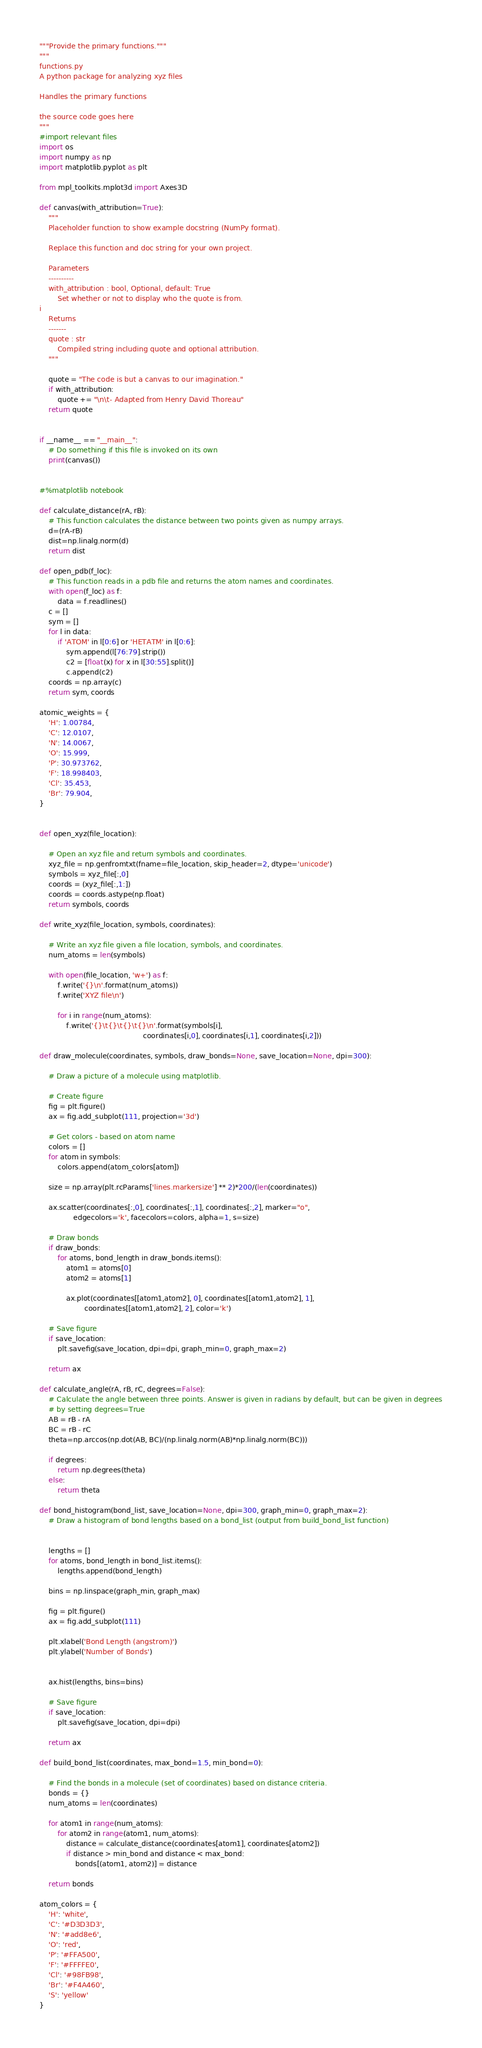Convert code to text. <code><loc_0><loc_0><loc_500><loc_500><_Python_>"""Provide the primary functions."""
"""
functions.py
A python package for analyzing xyz files

Handles the primary functions

the source code goes here
"""
#import relevant files
import os
import numpy as np
import matplotlib.pyplot as plt

from mpl_toolkits.mplot3d import Axes3D

def canvas(with_attribution=True):
    """
    Placeholder function to show example docstring (NumPy format).

    Replace this function and doc string for your own project.

    Parameters
    ----------
    with_attribution : bool, Optional, default: True
        Set whether or not to display who the quote is from.
i
    Returns
    -------
    quote : str
        Compiled string including quote and optional attribution.
    """

    quote = "The code is but a canvas to our imagination."
    if with_attribution:
        quote += "\n\t- Adapted from Henry David Thoreau"
    return quote


if __name__ == "__main__":
    # Do something if this file is invoked on its own
    print(canvas())


#%matplotlib notebook

def calculate_distance(rA, rB):
    # This function calculates the distance between two points given as numpy arrays.
    d=(rA-rB)
    dist=np.linalg.norm(d)
    return dist

def open_pdb(f_loc):
    # This function reads in a pdb file and returns the atom names and coordinates.
    with open(f_loc) as f:
        data = f.readlines()
    c = []
    sym = []
    for l in data:
        if 'ATOM' in l[0:6] or 'HETATM' in l[0:6]:
            sym.append(l[76:79].strip())
            c2 = [float(x) for x in l[30:55].split()]
            c.append(c2)
    coords = np.array(c)
    return sym, coords

atomic_weights = {
    'H': 1.00784,
    'C': 12.0107,
    'N': 14.0067,
    'O': 15.999,
    'P': 30.973762,
    'F': 18.998403,
    'Cl': 35.453,
    'Br': 79.904,
}


def open_xyz(file_location):
    
    # Open an xyz file and return symbols and coordinates.
    xyz_file = np.genfromtxt(fname=file_location, skip_header=2, dtype='unicode')
    symbols = xyz_file[:,0]
    coords = (xyz_file[:,1:])
    coords = coords.astype(np.float)
    return symbols, coords

def write_xyz(file_location, symbols, coordinates):
    
    # Write an xyz file given a file location, symbols, and coordinates.
    num_atoms = len(symbols)
    
    with open(file_location, 'w+') as f:
        f.write('{}\n'.format(num_atoms))
        f.write('XYZ file\n')
        
        for i in range(num_atoms):
            f.write('{}\t{}\t{}\t{}\n'.format(symbols[i], 
                                              coordinates[i,0], coordinates[i,1], coordinates[i,2]))

def draw_molecule(coordinates, symbols, draw_bonds=None, save_location=None, dpi=300):
    
    # Draw a picture of a molecule using matplotlib.
    
    # Create figure
    fig = plt.figure()
    ax = fig.add_subplot(111, projection='3d')
    
    # Get colors - based on atom name
    colors = []
    for atom in symbols:
        colors.append(atom_colors[atom])
    
    size = np.array(plt.rcParams['lines.markersize'] ** 2)*200/(len(coordinates))

    ax.scatter(coordinates[:,0], coordinates[:,1], coordinates[:,2], marker="o",
               edgecolors='k', facecolors=colors, alpha=1, s=size)
    
    # Draw bonds
    if draw_bonds:
        for atoms, bond_length in draw_bonds.items():
            atom1 = atoms[0]
            atom2 = atoms[1]
            
            ax.plot(coordinates[[atom1,atom2], 0], coordinates[[atom1,atom2], 1],
                    coordinates[[atom1,atom2], 2], color='k')
    
    # Save figure
    if save_location:
        plt.savefig(save_location, dpi=dpi, graph_min=0, graph_max=2)
    
    return ax

def calculate_angle(rA, rB, rC, degrees=False):
    # Calculate the angle between three points. Answer is given in radians by default, but can be given in degrees
    # by setting degrees=True
    AB = rB - rA
    BC = rB - rC
    theta=np.arccos(np.dot(AB, BC)/(np.linalg.norm(AB)*np.linalg.norm(BC)))

    if degrees:
        return np.degrees(theta)
    else:
        return theta

def bond_histogram(bond_list, save_location=None, dpi=300, graph_min=0, graph_max=2):
    # Draw a histogram of bond lengths based on a bond_list (output from build_bond_list function)
    
    
    lengths = []
    for atoms, bond_length in bond_list.items():
        lengths.append(bond_length)
    
    bins = np.linspace(graph_min, graph_max)
    
    fig = plt.figure()
    ax = fig.add_subplot(111)
    
    plt.xlabel('Bond Length (angstrom)')
    plt.ylabel('Number of Bonds')
    
    
    ax.hist(lengths, bins=bins)
    
    # Save figure
    if save_location:
        plt.savefig(save_location, dpi=dpi)
    
    return ax
        
def build_bond_list(coordinates, max_bond=1.5, min_bond=0):
    
    # Find the bonds in a molecule (set of coordinates) based on distance criteria.
    bonds = {}
    num_atoms = len(coordinates)

    for atom1 in range(num_atoms):
        for atom2 in range(atom1, num_atoms):
            distance = calculate_distance(coordinates[atom1], coordinates[atom2])
            if distance > min_bond and distance < max_bond:
                bonds[(atom1, atom2)] = distance

    return bonds

atom_colors = {
    'H': 'white',
    'C': '#D3D3D3',
    'N': '#add8e6',
    'O': 'red',
    'P': '#FFA500',
    'F': '#FFFFE0',
    'Cl': '#98FB98',
    'Br': '#F4A460',
    'S': 'yellow'
}


</code> 